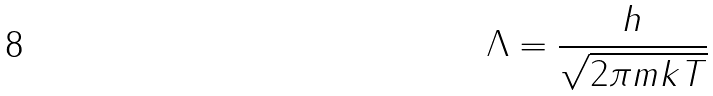<formula> <loc_0><loc_0><loc_500><loc_500>\Lambda = \frac { h } { \sqrt { 2 \pi m k T } }</formula> 